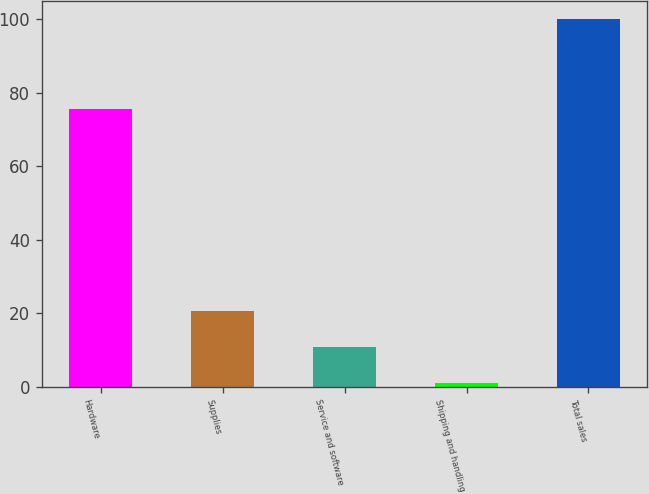<chart> <loc_0><loc_0><loc_500><loc_500><bar_chart><fcel>Hardware<fcel>Supplies<fcel>Service and software<fcel>Shipping and handling<fcel>Total sales<nl><fcel>75.7<fcel>20.72<fcel>10.81<fcel>0.9<fcel>100<nl></chart> 